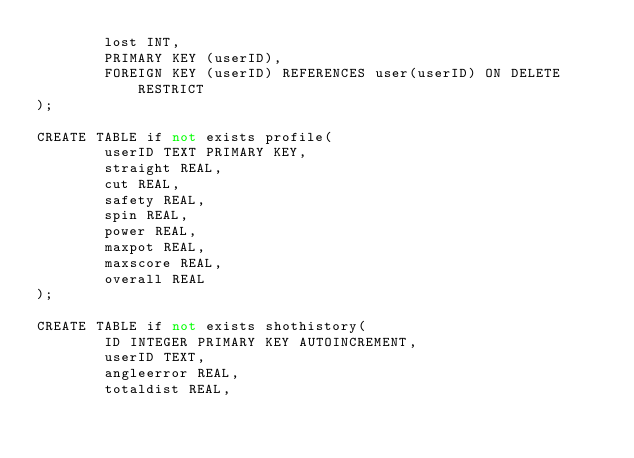Convert code to text. <code><loc_0><loc_0><loc_500><loc_500><_SQL_>        lost INT,
        PRIMARY KEY (userID),
        FOREIGN KEY (userID) REFERENCES user(userID) ON DELETE RESTRICT
);

CREATE TABLE if not exists profile(
        userID TEXT PRIMARY KEY,
        straight REAL,
        cut REAL,
        safety REAL,
        spin REAL,
        power REAL,
        maxpot REAL,
        maxscore REAL,
        overall REAL
);

CREATE TABLE if not exists shothistory(
        ID INTEGER PRIMARY KEY AUTOINCREMENT,
        userID TEXT,
        angleerror REAL,
        totaldist REAL,</code> 